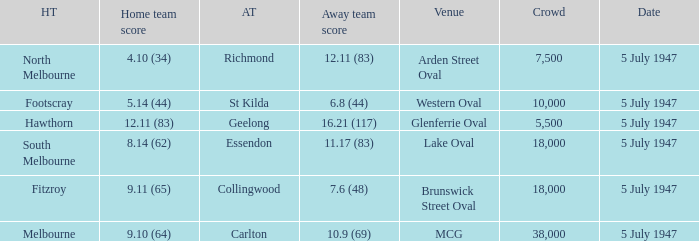What away team played against Footscray as the home team? St Kilda. 